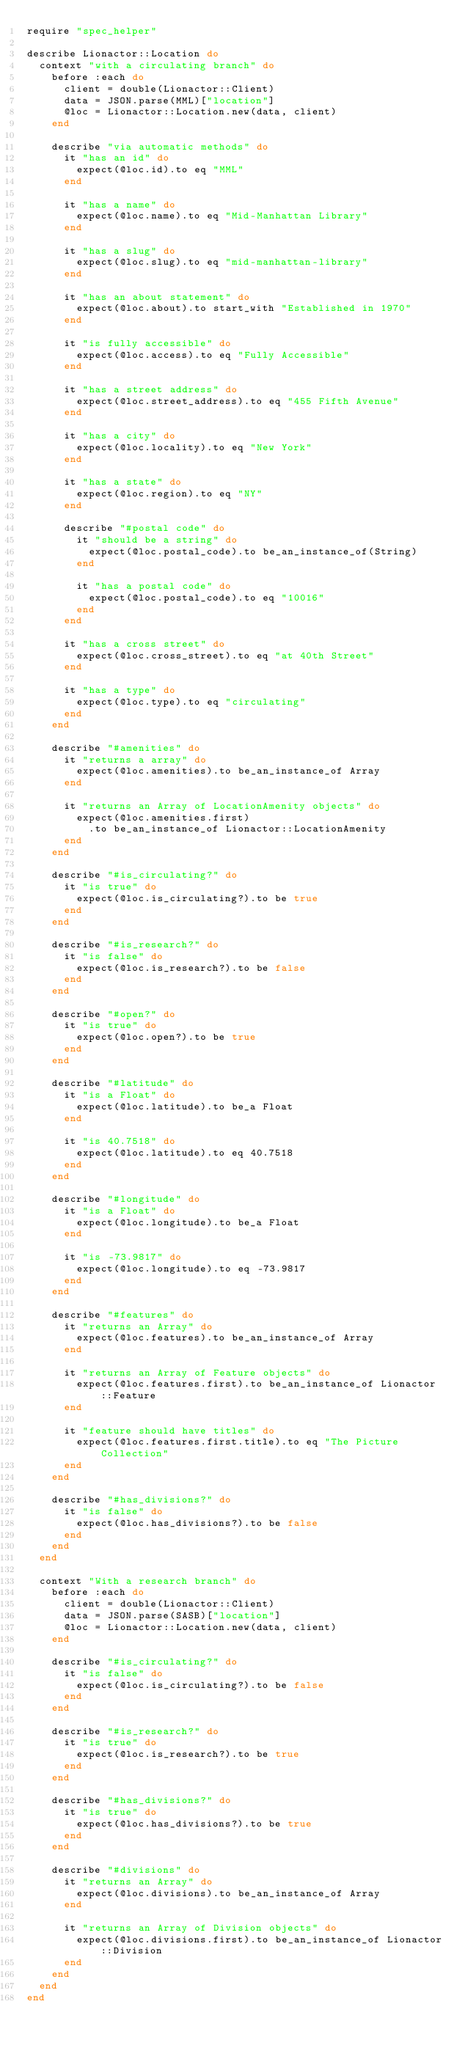<code> <loc_0><loc_0><loc_500><loc_500><_Ruby_>require "spec_helper"

describe Lionactor::Location do
  context "with a circulating branch" do
    before :each do
      client = double(Lionactor::Client)
      data = JSON.parse(MML)["location"]
      @loc = Lionactor::Location.new(data, client)
    end

    describe "via automatic methods" do
      it "has an id" do
        expect(@loc.id).to eq "MML"
      end

      it "has a name" do
        expect(@loc.name).to eq "Mid-Manhattan Library"
      end

      it "has a slug" do
        expect(@loc.slug).to eq "mid-manhattan-library"
      end

      it "has an about statement" do
        expect(@loc.about).to start_with "Established in 1970"
      end

      it "is fully accessible" do
        expect(@loc.access).to eq "Fully Accessible"
      end

      it "has a street address" do
        expect(@loc.street_address).to eq "455 Fifth Avenue"
      end

      it "has a city" do
        expect(@loc.locality).to eq "New York"
      end

      it "has a state" do
        expect(@loc.region).to eq "NY"
      end

      describe "#postal code" do
        it "should be a string" do
          expect(@loc.postal_code).to be_an_instance_of(String)
        end

        it "has a postal code" do
          expect(@loc.postal_code).to eq "10016"
        end
      end

      it "has a cross street" do
        expect(@loc.cross_street).to eq "at 40th Street"
      end

      it "has a type" do
        expect(@loc.type).to eq "circulating"
      end      
    end

    describe "#amenities" do
      it "returns a array" do
        expect(@loc.amenities).to be_an_instance_of Array
      end

      it "returns an Array of LocationAmenity objects" do
        expect(@loc.amenities.first)
          .to be_an_instance_of Lionactor::LocationAmenity
      end
    end

    describe "#is_circulating?" do
      it "is true" do
        expect(@loc.is_circulating?).to be true
      end
    end

    describe "#is_research?" do
      it "is false" do
        expect(@loc.is_research?).to be false
      end
    end

    describe "#open?" do
      it "is true" do
        expect(@loc.open?).to be true
      end
    end

    describe "#latitude" do
      it "is a Float" do
        expect(@loc.latitude).to be_a Float
      end

      it "is 40.7518" do
        expect(@loc.latitude).to eq 40.7518
      end
    end

    describe "#longitude" do
      it "is a Float" do
        expect(@loc.longitude).to be_a Float
      end

      it "is -73.9817" do
        expect(@loc.longitude).to eq -73.9817
      end
    end

    describe "#features" do
      it "returns an Array" do
        expect(@loc.features).to be_an_instance_of Array
      end

      it "returns an Array of Feature objects" do
        expect(@loc.features.first).to be_an_instance_of Lionactor::Feature
      end

      it "feature should have titles" do
        expect(@loc.features.first.title).to eq "The Picture Collection"
      end
    end

    describe "#has_divisions?" do
      it "is false" do
        expect(@loc.has_divisions?).to be false
      end
    end
  end

  context "With a research branch" do
    before :each do
      client = double(Lionactor::Client)
      data = JSON.parse(SASB)["location"]
      @loc = Lionactor::Location.new(data, client)
    end

    describe "#is_circulating?" do
      it "is false" do
        expect(@loc.is_circulating?).to be false
      end
    end

    describe "#is_research?" do
      it "is true" do
        expect(@loc.is_research?).to be true
      end
    end

    describe "#has_divisions?" do
      it "is true" do
        expect(@loc.has_divisions?).to be true
      end
    end

    describe "#divisions" do
      it "returns an Array" do
        expect(@loc.divisions).to be_an_instance_of Array
      end

      it "returns an Array of Division objects" do
        expect(@loc.divisions.first).to be_an_instance_of Lionactor::Division
      end
    end
  end
end
 
</code> 